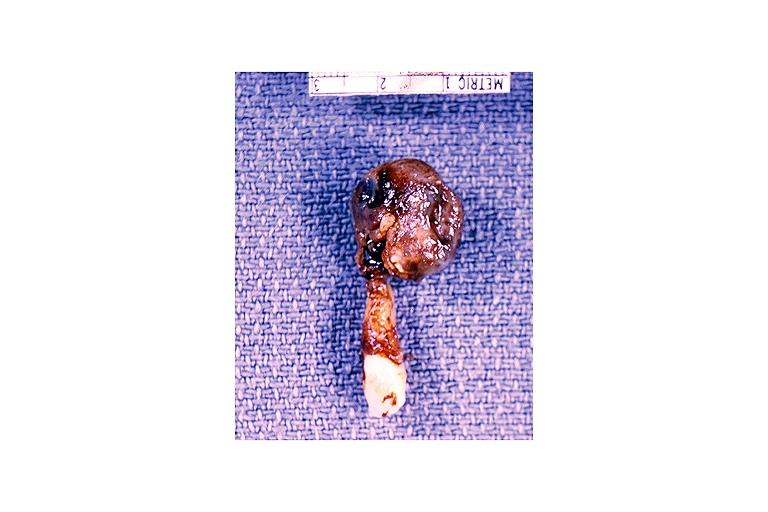where is this?
Answer the question using a single word or phrase. Oral 